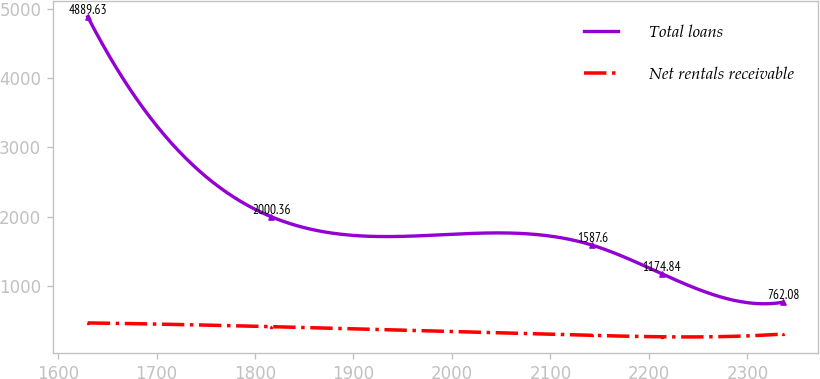Convert chart. <chart><loc_0><loc_0><loc_500><loc_500><line_chart><ecel><fcel>Total loans<fcel>Net rentals receivable<nl><fcel>1630.11<fcel>4889.63<fcel>463.04<nl><fcel>1816.11<fcel>2000.36<fcel>409.19<nl><fcel>2142.32<fcel>1587.6<fcel>282.57<nl><fcel>2212.91<fcel>1174.84<fcel>262.52<nl><fcel>2336.03<fcel>762.08<fcel>302.62<nl></chart> 